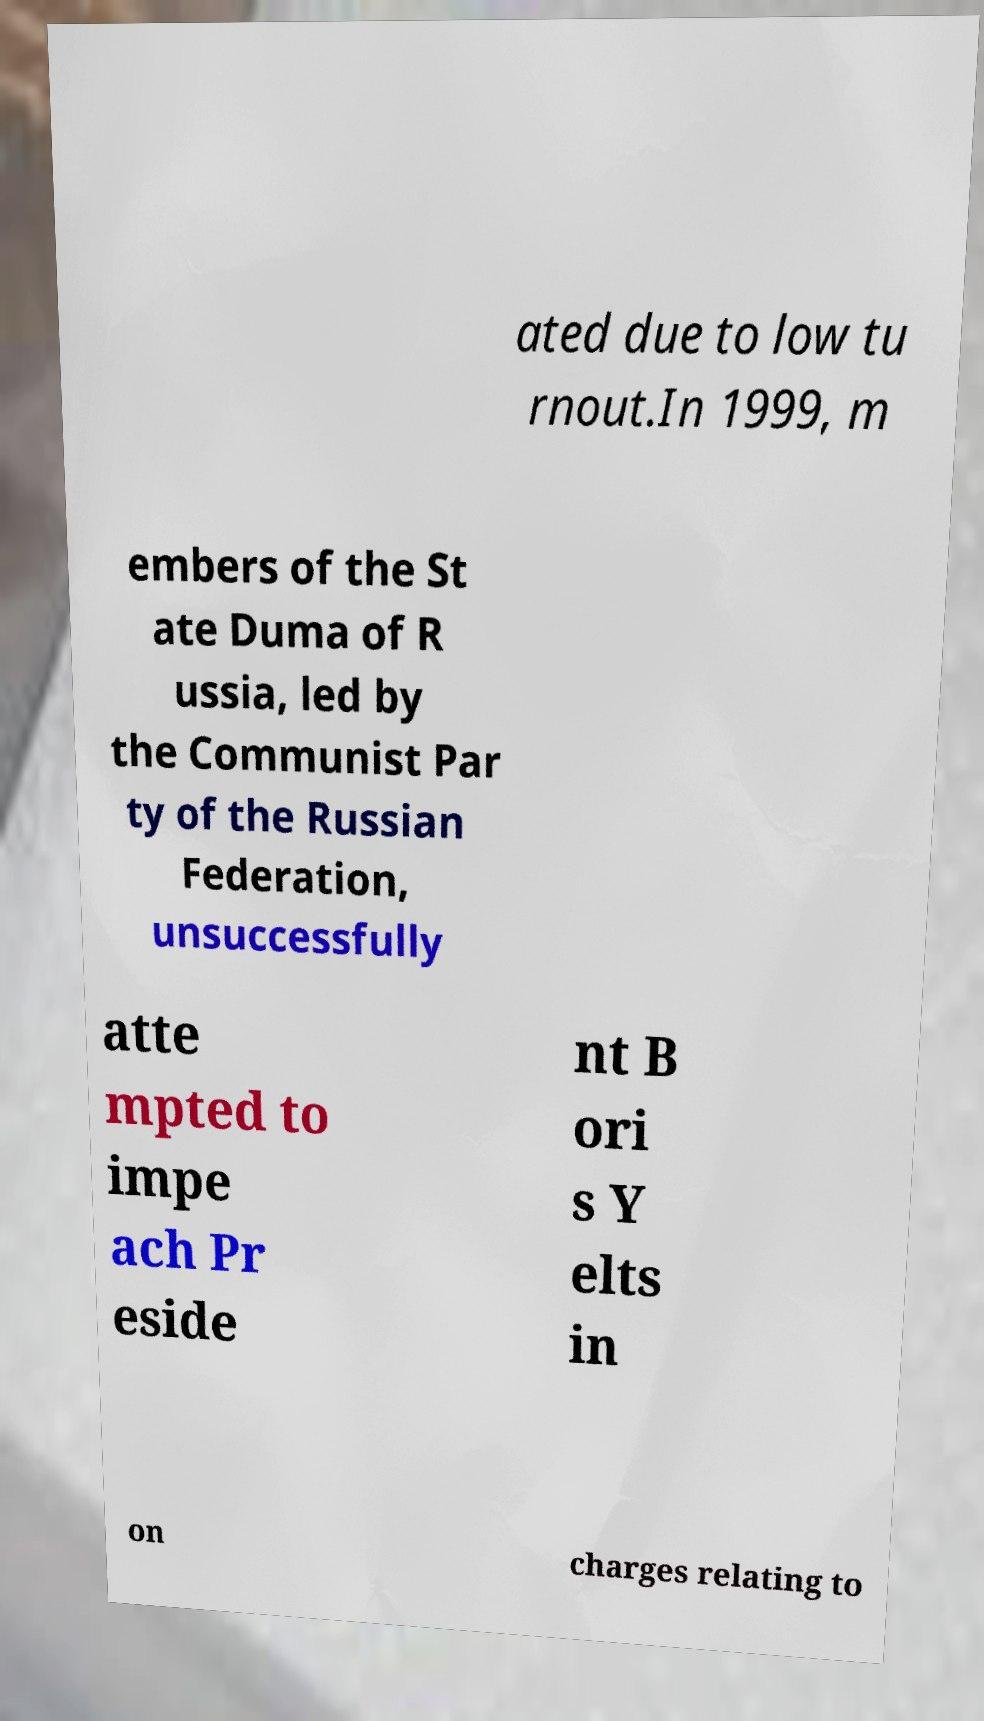Please read and relay the text visible in this image. What does it say? ated due to low tu rnout.In 1999, m embers of the St ate Duma of R ussia, led by the Communist Par ty of the Russian Federation, unsuccessfully atte mpted to impe ach Pr eside nt B ori s Y elts in on charges relating to 